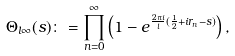Convert formula to latex. <formula><loc_0><loc_0><loc_500><loc_500>\Theta _ { l \infty } ( s ) \colon = \prod _ { n = 0 } ^ { \infty } \left ( 1 - e ^ { \frac { 2 \pi i } { l } ( \frac { 1 } { 2 } + i r _ { n } - s ) } \right ) ,</formula> 